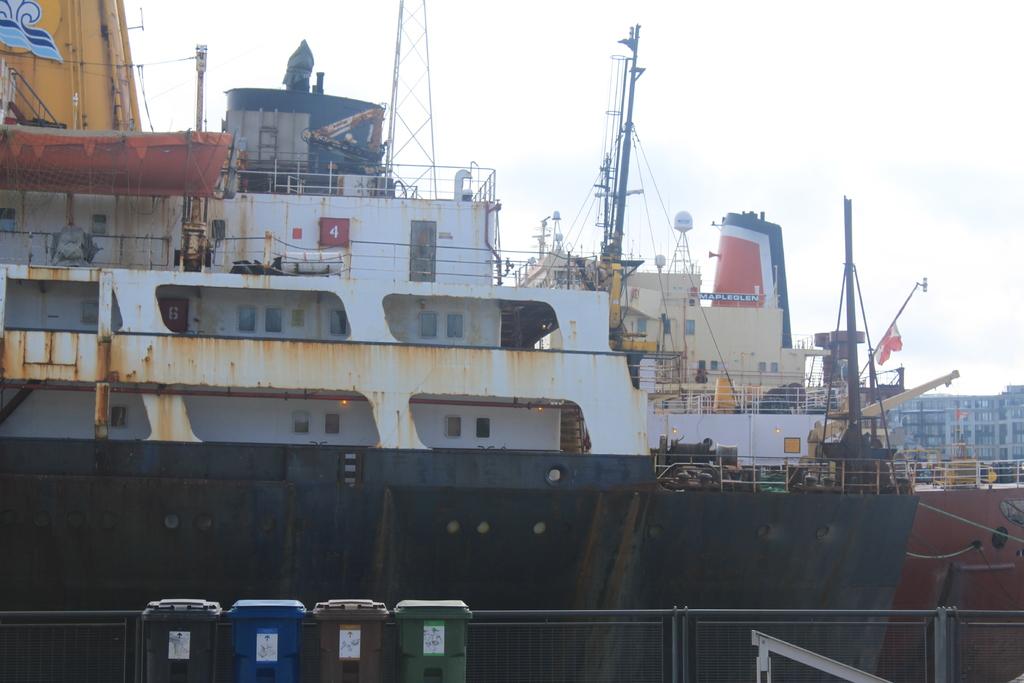What number is on the boat?
Your answer should be compact. 4. 